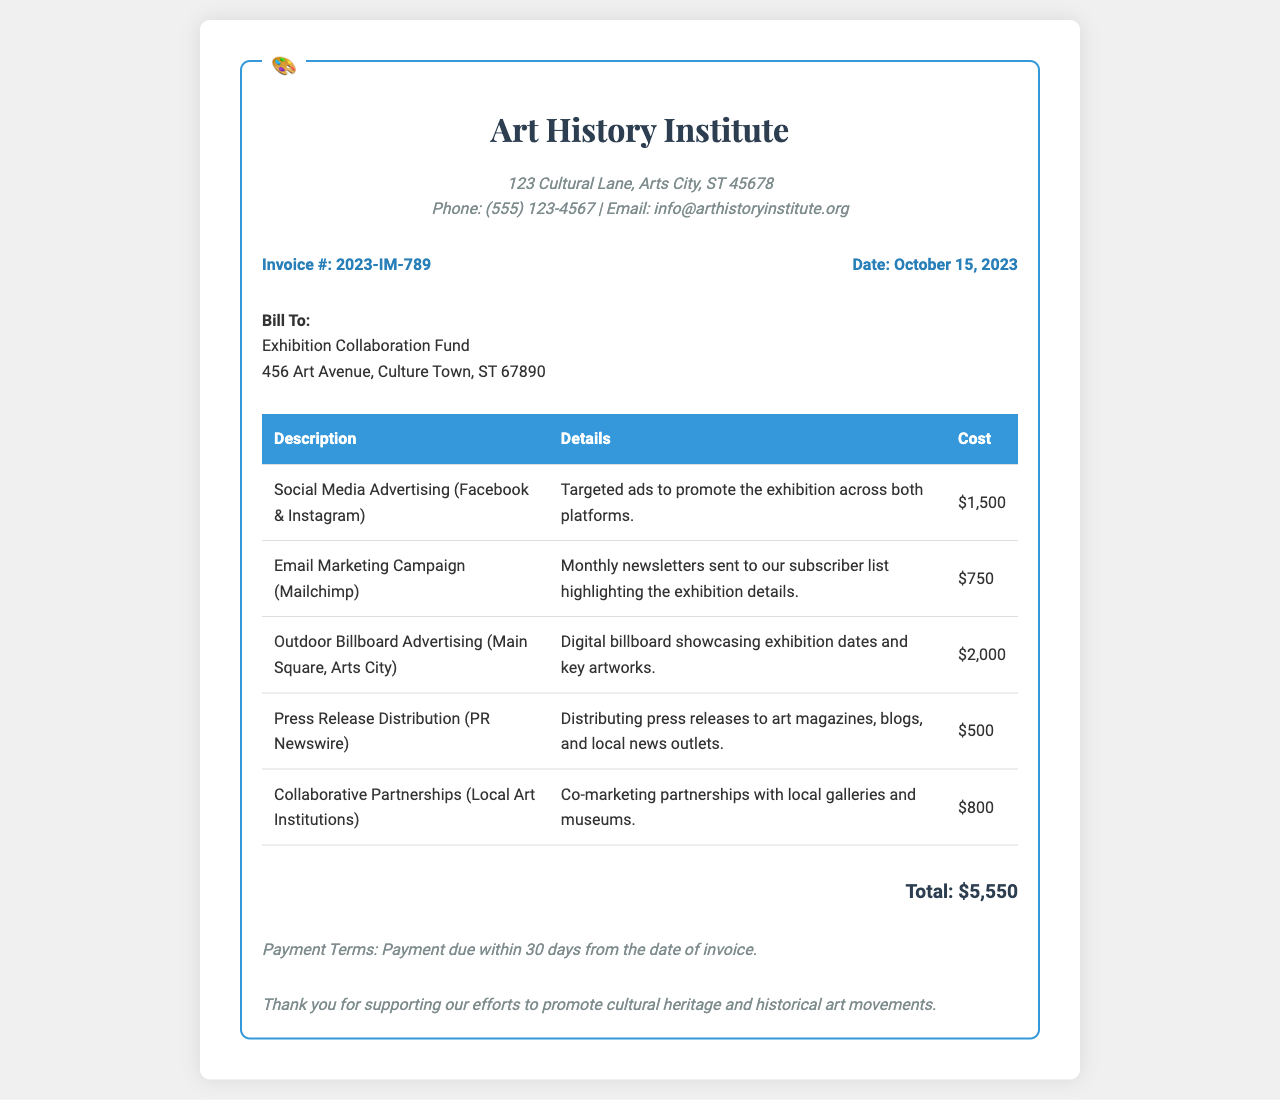what is the invoice number? The invoice number is indicated prominently in the document as a specific identifier for the billing.
Answer: 2023-IM-789 what is the total cost for the marketing services? The total cost is the sum of all individual costs listed in the invoice.
Answer: $5,550 what platform is used for email marketing? The platform used for email marketing is mentioned in the details of the service provided.
Answer: Mailchimp how much was spent on outdoor billboard advertising? The cost for outdoor billboard advertising is explicitly stated in the document.
Answer: $2,000 what is the payment term for this invoice? The payment term specifies the duration within which the payment needs to be completed after the invoice date.
Answer: Payment due within 30 days from the date of invoice which organization is the invoice addressed to? The recipient name can be found in the section dedicated to billing information.
Answer: Exhibition Collaboration Fund what type of advertising is the most expensive? The types of services include different advertising methods, and the most expensive one is distinguished by its cost.
Answer: Outdoor Billboard Advertising how many services are listed in the invoice? The number of services provided can be counted from the entries in the table of services and their costs.
Answer: 5 what is the date of the invoice? The date of the invoice is crucial for tracking payment terms.
Answer: October 15, 2023 